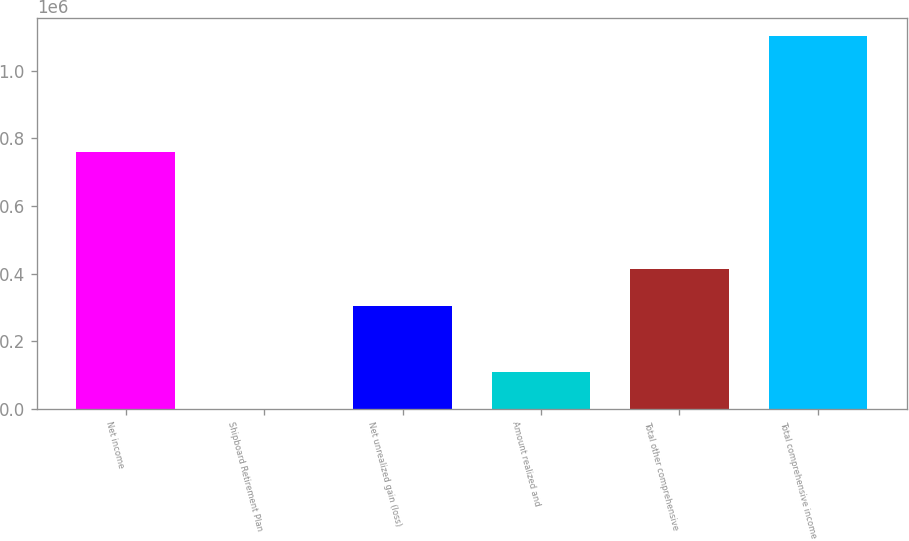<chart> <loc_0><loc_0><loc_500><loc_500><bar_chart><fcel>Net income<fcel>Shipboard Retirement Plan<fcel>Net unrealized gain (loss)<fcel>Amount realized and<fcel>Total other comprehensive<fcel>Total comprehensive income<nl><fcel>759872<fcel>40<fcel>304684<fcel>110167<fcel>414811<fcel>1.10131e+06<nl></chart> 